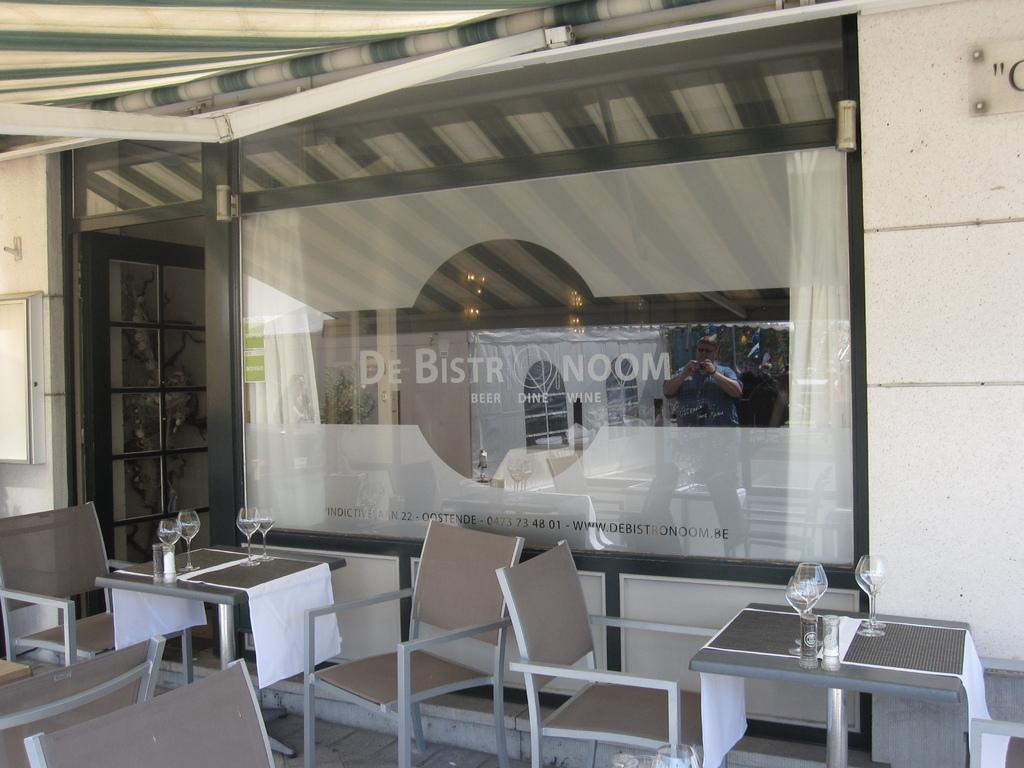What is the name of the company?
Provide a short and direct response. De bistr noom. 